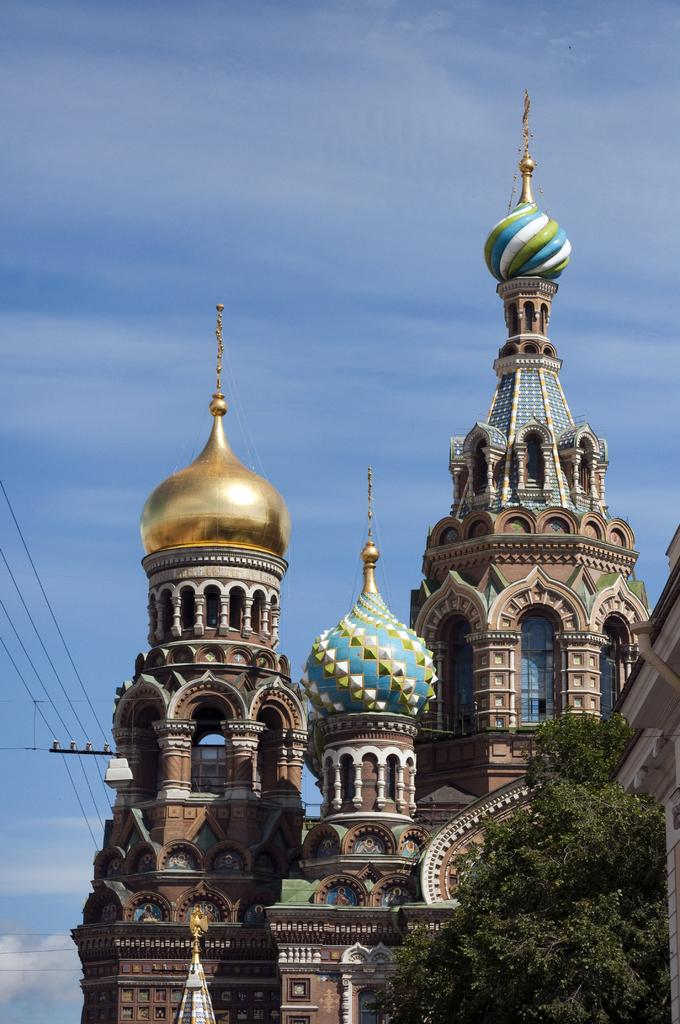What is located at the front of the image? There is a tree in the front of the image. What can be seen in the background of the image? There are towers in the background of the image. What structure is on the right side of the image? There is a building on the right side of the image. How would you describe the sky in the image? The sky is cloudy in the image. What else is visible in the image besides the tree, towers, building, and sky? There are wires visible in the image. How many buttons are on the tree in the image? There are no buttons present on the tree in the image. What type of wealth is depicted in the image? There is no depiction of wealth in the image; it features a tree, towers, a building, a cloudy sky, and wires. 